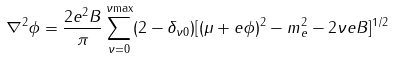Convert formula to latex. <formula><loc_0><loc_0><loc_500><loc_500>\nabla ^ { 2 } \phi = \frac { 2 e ^ { 2 } B } { \pi } \sum _ { \nu = 0 } ^ { \nu { \max } } ( 2 - \delta _ { \nu 0 } ) [ ( \mu + e \phi ) ^ { 2 } - m _ { e } ^ { 2 } - 2 \nu e B ] ^ { 1 / 2 }</formula> 